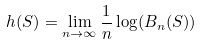Convert formula to latex. <formula><loc_0><loc_0><loc_500><loc_500>h ( S ) = \lim _ { n \to \infty } \frac { 1 } { n } \log ( B _ { n } ( S ) )</formula> 